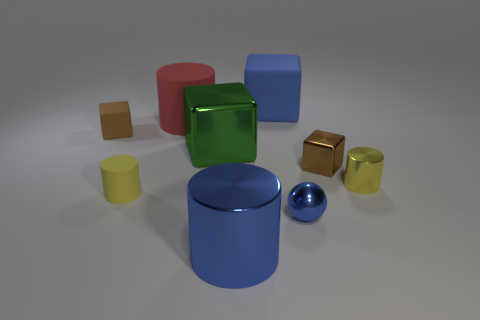The shiny cube that is to the right of the tiny blue metal ball is what color? The shiny cube situated to the right of the diminutive blue metallic sphere exhibits a reflective green surface, casting subtle highlights and softly mirroring its surroundings. 